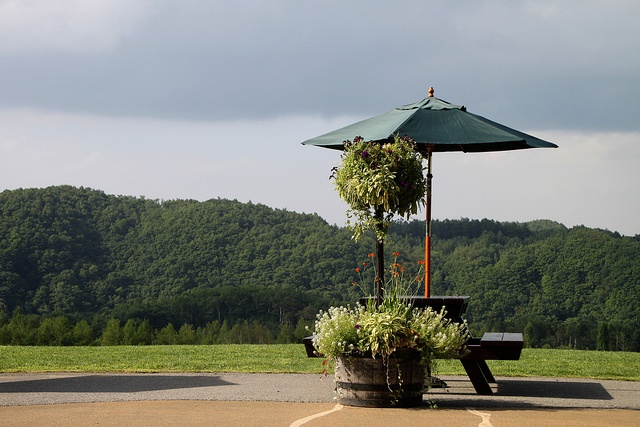Describe the objects in this image and their specific colors. I can see potted plant in lightgray, black, olive, and gray tones, umbrella in lightgray, black, darkgray, purple, and teal tones, potted plant in lightgray, black, olive, and gray tones, bench in lightgray, black, gray, and olive tones, and bench in lightgray, black, darkgreen, gray, and darkgray tones in this image. 